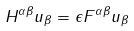<formula> <loc_0><loc_0><loc_500><loc_500>H ^ { \alpha \beta } u _ { \beta } = \epsilon F ^ { \alpha \beta } u _ { \beta }</formula> 